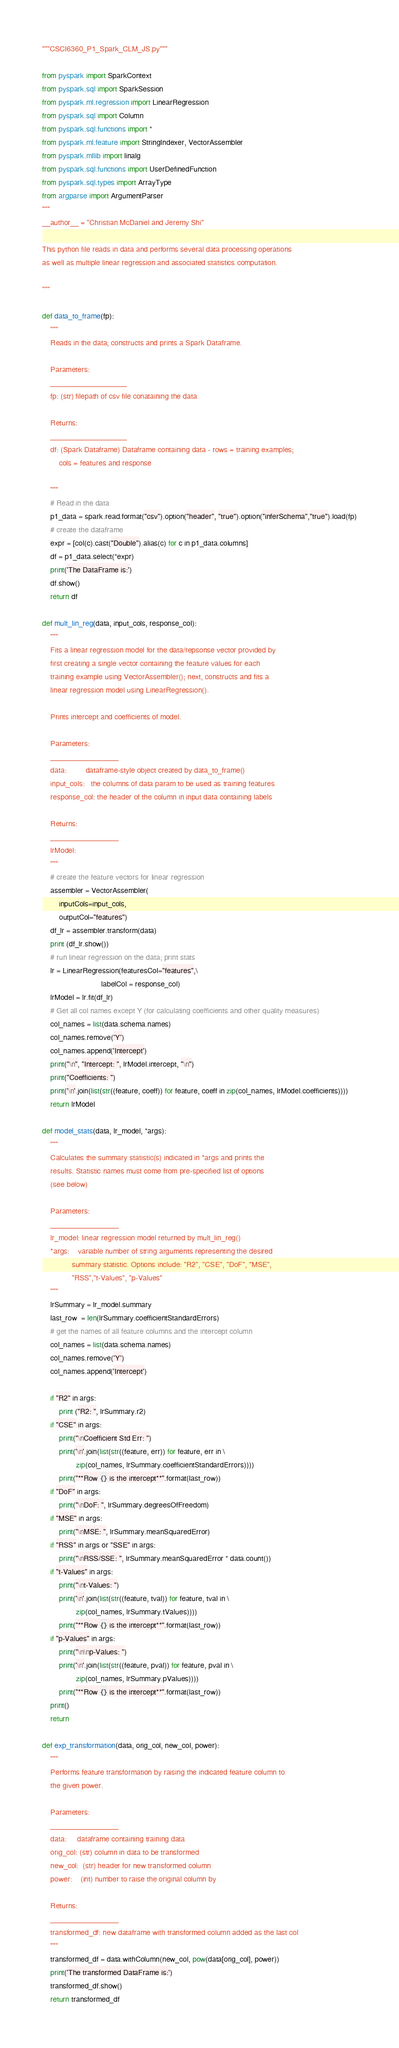Convert code to text. <code><loc_0><loc_0><loc_500><loc_500><_Python_>"""CSCI6360_P1_Spark_CLM_JS.py"""

from pyspark import SparkContext
from pyspark.sql import SparkSession
from pyspark.ml.regression import LinearRegression
from pyspark.sql import Column
from pyspark.sql.functions import *
from pyspark.ml.feature import StringIndexer, VectorAssembler
from pyspark.mllib import linalg
from pyspark.sql.functions import UserDefinedFunction
from pyspark.sql.types import ArrayType
from argparse import ArgumentParser
"""
__author__ = "Christian McDaniel and Jeremy Shi"

This python file reads in data and performs several data processing operations
as well as multiple linear regression and associated statistics computation.

"""

def data_to_frame(fp):
    """
    Reads in the data; constructs and prints a Spark Dataframe.

    Parameters:
    ___________________
    fp: (str) filepath of csv file conataining the data

    Returns:
    ___________________
    df: (Spark Dataframe) Dataframe containing data - rows = training examples;
        cols = features and response

    """
    # Read in the data
    p1_data = spark.read.format("csv").option("header", "true").option("inferSchema","true").load(fp)
    # create the dataframe
    expr = [col(c).cast("Double").alias(c) for c in p1_data.columns]
    df = p1_data.select(*expr)
    print('The DataFrame is:')
    df.show()
    return df

def mult_lin_reg(data, input_cols, response_col):
    """
    Fits a linear regression model for the data/repsonse vector provided by
    first creating a single vector containing the feature values for each
    training example using VectorAssembler(); next, constructs and fits a
    linear regression model using LinearRegression().

    Prints intercept and coefficients of model.

    Parameters:
    _________________
    data:         dataframe-style object created by data_to_frame()
    input_cols:   the columns of data param to be used as training features
    response_col: the header of the column in input data containing labels

    Returns:
    _________________
    lrModel:
    """
    # create the feature vectors for linear regression
    assembler = VectorAssembler(
        inputCols=input_cols,
        outputCol="features")
    df_lr = assembler.transform(data)
    print (df_lr.show())
    # run linear regression on the data; print stats
    lr = LinearRegression(featuresCol="features",\
                            labelCol = response_col)
    lrModel = lr.fit(df_lr)
    # Get all col names except Y (for calculating coefficients and other quality measures)
    col_names = list(data.schema.names)
    col_names.remove('Y')
    col_names.append('Intercept')
    print("\n", "Intercept: ", lrModel.intercept, "\n")
    print("Coefficients: ")
    print('\n'.join(list(str((feature, coeff)) for feature, coeff in zip(col_names, lrModel.coefficients))))
    return lrModel

def model_stats(data, lr_model, *args):
    """
    Calculates the summary statistic(s) indicated in *args and prints the
    results. Statistic names must come from pre-specified list of options
    (see below)

    Parameters:
    _________________
    lr_model: linear regression model returned by mult_lin_reg()
    *args:    variable number of string arguments representing the desired
              summary statistic. Options include: "R2", "CSE", "DoF", "MSE",
              "RSS","t-Values", "p-Values"
    """
    lrSummary = lr_model.summary
    last_row  = len(lrSummary.coefficientStandardErrors)
    # get the names of all feature columns and the intercept column
    col_names = list(data.schema.names)
    col_names.remove('Y')
    col_names.append('Intercept')

    if "R2" in args:
        print ("R2: ", lrSummary.r2)
    if "CSE" in args:
        print("\nCoefficient Std Err: ")
        print('\n'.join(list(str((feature, err)) for feature, err in \
                zip(col_names, lrSummary.coefficientStandardErrors))))
        print("**Row {} is the intercept**".format(last_row))
    if "DoF" in args:
        print("\nDoF: ", lrSummary.degreesOfFreedom)
    if "MSE" in args:
        print("\nMSE: ", lrSummary.meanSquaredError)
    if "RSS" in args or "SSE" in args:
        print("\nRSS/SSE: ", lrSummary.meanSquaredError * data.count())
    if "t-Values" in args:
        print("\nt-Values: ")
        print('\n'.join(list(str((feature, tval)) for feature, tval in \
                zip(col_names, lrSummary.tValues))))
        print("**Row {} is the intercept**".format(last_row))
    if "p-Values" in args:
        print("\n\np-Values: ")
        print('\n'.join(list(str((feature, pval)) for feature, pval in \
                zip(col_names, lrSummary.pValues))))
        print("**Row {} is the intercept**".format(last_row))
    print()
    return

def exp_transformation(data, orig_col, new_col, power):
    """
    Performs feature transformation by raising the indicated feature column to
    the given power.

    Parameters:
    _________________
    data:     dataframe containing training data
    orig_col: (str) column in data to be transformed
    new_col:  (str) header for new transformed column
    power:    (int) number to raise the original column by

    Returns:
    _________________
    transformed_df: new dataframe with transformed column added as the last col
    """
    transformed_df = data.withColumn(new_col, pow(data[orig_col], power))
    print('The transformed DataFrame is:')
    transformed_df.show()
    return transformed_df
</code> 